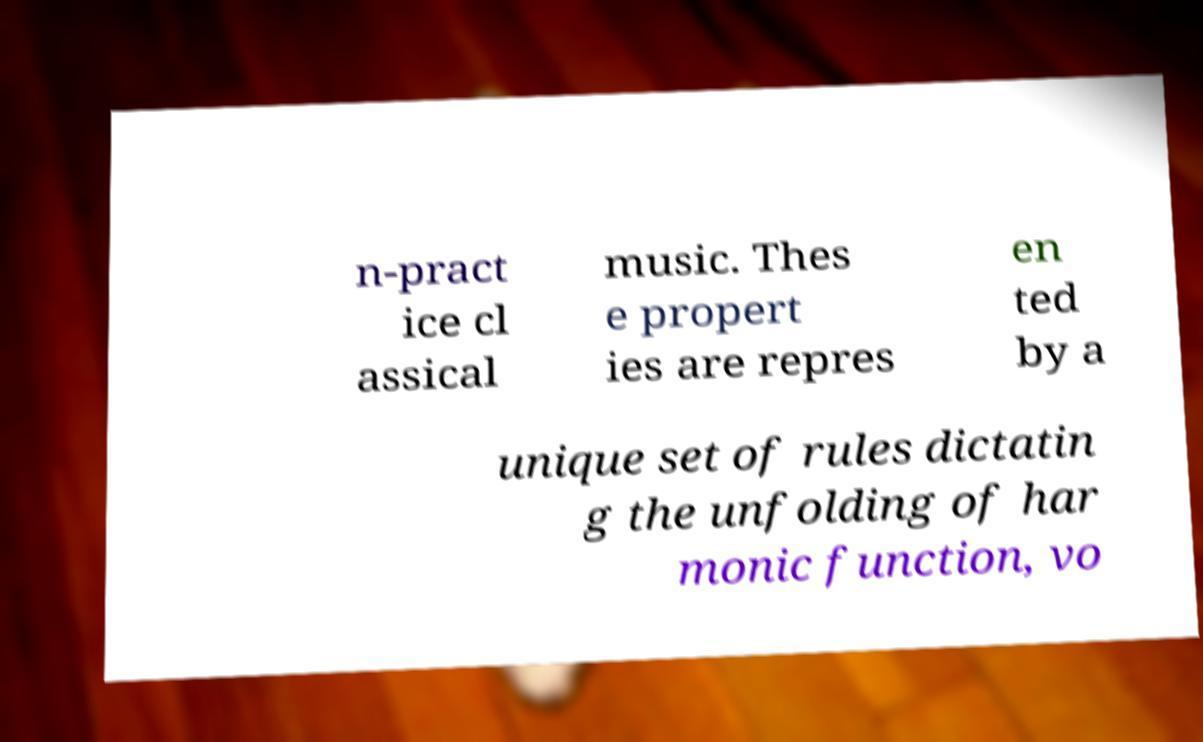I need the written content from this picture converted into text. Can you do that? n-pract ice cl assical music. Thes e propert ies are repres en ted by a unique set of rules dictatin g the unfolding of har monic function, vo 